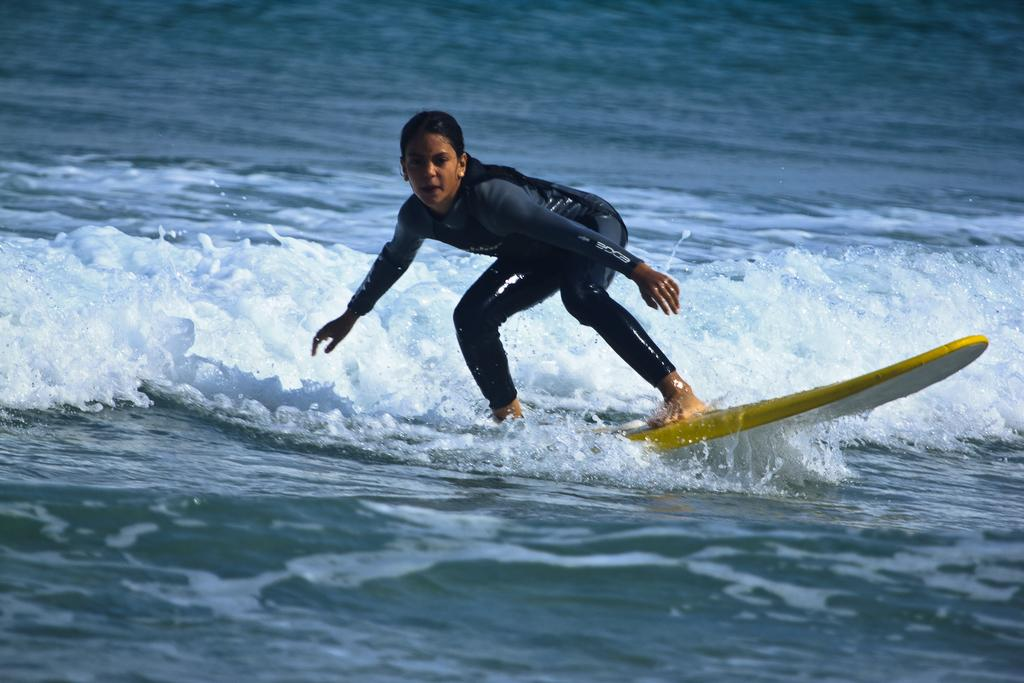What is the main subject of the image? There is a person in the image. What is the person doing in the image? The person is on a surfboard. Where is the surfboard located in the image? The surfboard is on the water. What is the existence of the surfboard like in the image? The question seems to be asking about the existence of the surfboard, which is already established in the facts provided. The surfboard is present and visible in the image. What is the smell of the water in the image? The image is a visual representation, and there is no information provided about the smell of the water. --- 